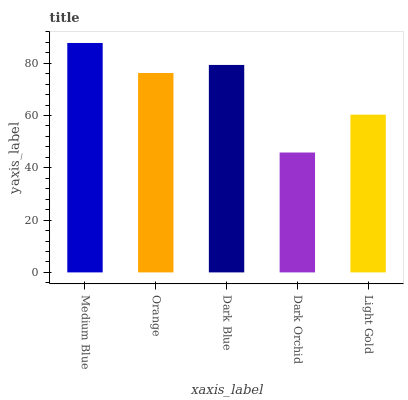Is Dark Orchid the minimum?
Answer yes or no. Yes. Is Medium Blue the maximum?
Answer yes or no. Yes. Is Orange the minimum?
Answer yes or no. No. Is Orange the maximum?
Answer yes or no. No. Is Medium Blue greater than Orange?
Answer yes or no. Yes. Is Orange less than Medium Blue?
Answer yes or no. Yes. Is Orange greater than Medium Blue?
Answer yes or no. No. Is Medium Blue less than Orange?
Answer yes or no. No. Is Orange the high median?
Answer yes or no. Yes. Is Orange the low median?
Answer yes or no. Yes. Is Light Gold the high median?
Answer yes or no. No. Is Medium Blue the low median?
Answer yes or no. No. 